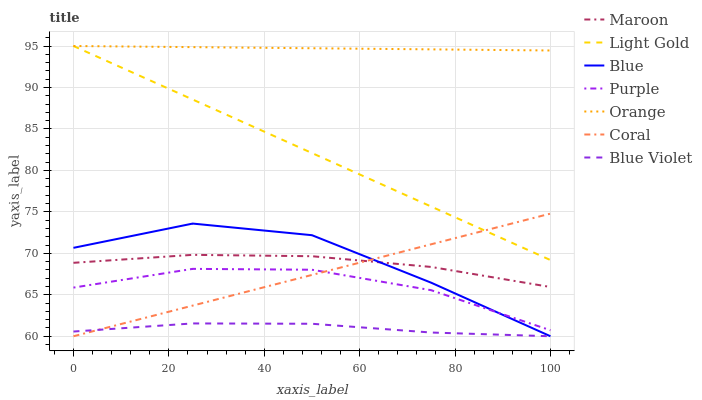Does Blue Violet have the minimum area under the curve?
Answer yes or no. Yes. Does Orange have the maximum area under the curve?
Answer yes or no. Yes. Does Purple have the minimum area under the curve?
Answer yes or no. No. Does Purple have the maximum area under the curve?
Answer yes or no. No. Is Coral the smoothest?
Answer yes or no. Yes. Is Blue the roughest?
Answer yes or no. Yes. Is Purple the smoothest?
Answer yes or no. No. Is Purple the roughest?
Answer yes or no. No. Does Blue have the lowest value?
Answer yes or no. Yes. Does Purple have the lowest value?
Answer yes or no. No. Does Light Gold have the highest value?
Answer yes or no. Yes. Does Purple have the highest value?
Answer yes or no. No. Is Blue Violet less than Light Gold?
Answer yes or no. Yes. Is Orange greater than Blue Violet?
Answer yes or no. Yes. Does Orange intersect Light Gold?
Answer yes or no. Yes. Is Orange less than Light Gold?
Answer yes or no. No. Is Orange greater than Light Gold?
Answer yes or no. No. Does Blue Violet intersect Light Gold?
Answer yes or no. No. 